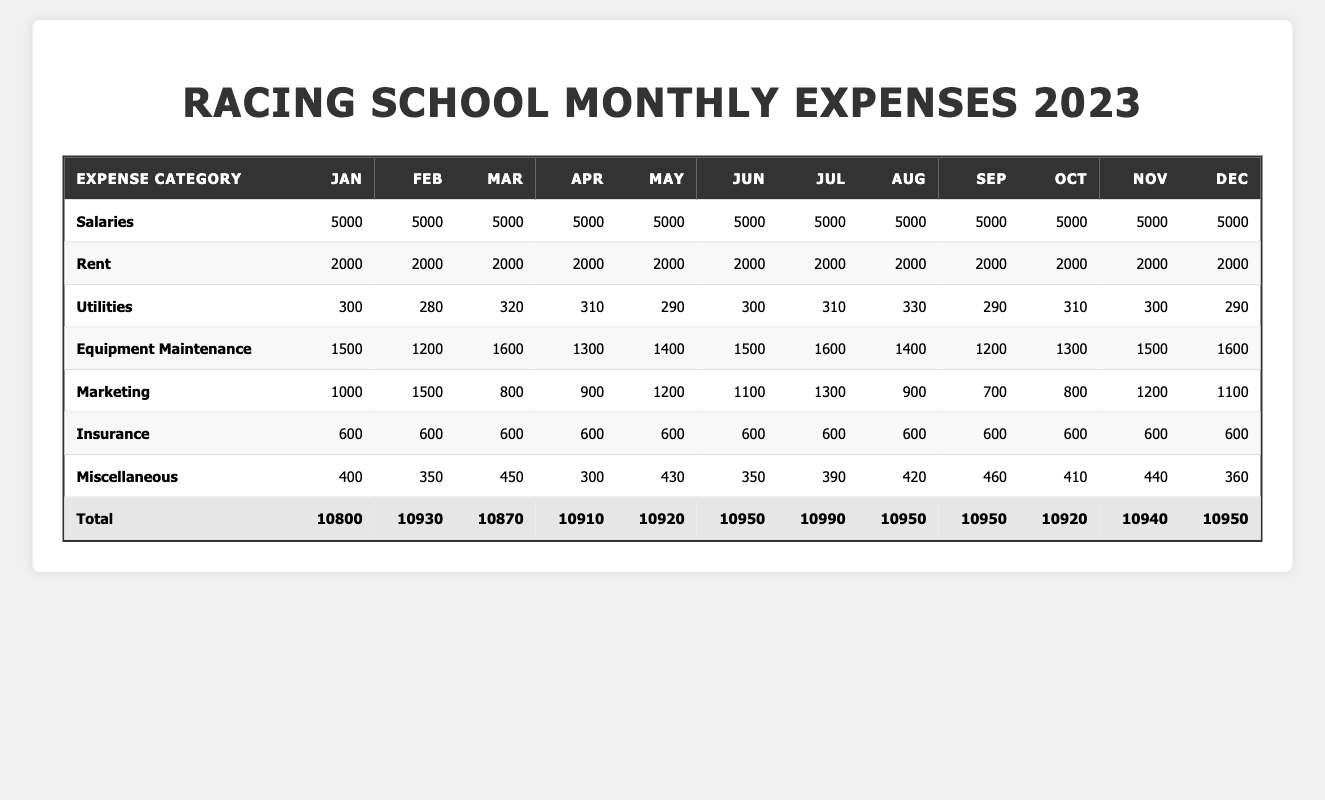What is the total expense for the racing school in March? According to the table, the total expenses for March are listed as 10870.
Answer: 10870 Which month had the highest equipment maintenance cost? Looking at the table, July has the highest equipment maintenance cost of 1600.
Answer: July What is the average monthly rent expense for the racing school in 2023? The rent expense is constant at 2000 for each month. Adding these gives 2000*12 = 24000, and dividing by 12 yields an average of 2000.
Answer: 2000 Did the expenses for utilities increase or decrease from January to June? In January, utilities were 300, and in June they were 300 as well, indicating no change.
Answer: No change What is the total of miscellaneous expenses for the entire year? By summing each month's miscellaneous expenses: 400 + 350 + 450 + 300 + 430 + 350 + 390 + 420 + 460 + 410 + 440 + 360 = 4500.
Answer: 4500 Which month had the lowest total expenses, and what was that amount? The lowest total was in January at 10800.
Answer: January, 10800 What is the difference in total expenses between June and November? June's total is 10950, and November's total is 10940. The difference is 10950 - 10940 = 10.
Answer: 10 Is the total expense for December more than the average monthly expense for the year? The total for December is 10950. The average monthly expense over the year can be calculated as (Total of all monthly totals: 10800 + 10930 + 10870 + 10910 + 10920 + 10950 + 10990 + 10950 + 10950 + 10920 + 10940 + 10950 = 130860) divided by 12, which is 10905. Since 10950 is greater than 10905, the statement is true.
Answer: Yes Which category had the highest cumulative expense over the year? Summing all categories shows that Salaries total 60000 (5000 * 12), making it the highest cumulative expense.
Answer: Salaries How much did the marketing expenses total for the year? Adding the marketing expenses gives: 1000 + 1500 + 800 + 900 + 1200 + 1100 + 1300 + 900 + 700 + 800 + 1200 + 1100 = 13000.
Answer: 13000 